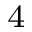Convert formula to latex. <formula><loc_0><loc_0><loc_500><loc_500>^ { \, 4 }</formula> 